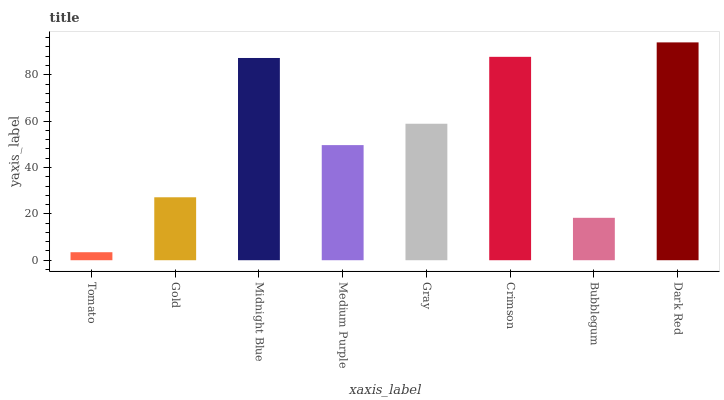Is Tomato the minimum?
Answer yes or no. Yes. Is Dark Red the maximum?
Answer yes or no. Yes. Is Gold the minimum?
Answer yes or no. No. Is Gold the maximum?
Answer yes or no. No. Is Gold greater than Tomato?
Answer yes or no. Yes. Is Tomato less than Gold?
Answer yes or no. Yes. Is Tomato greater than Gold?
Answer yes or no. No. Is Gold less than Tomato?
Answer yes or no. No. Is Gray the high median?
Answer yes or no. Yes. Is Medium Purple the low median?
Answer yes or no. Yes. Is Dark Red the high median?
Answer yes or no. No. Is Crimson the low median?
Answer yes or no. No. 